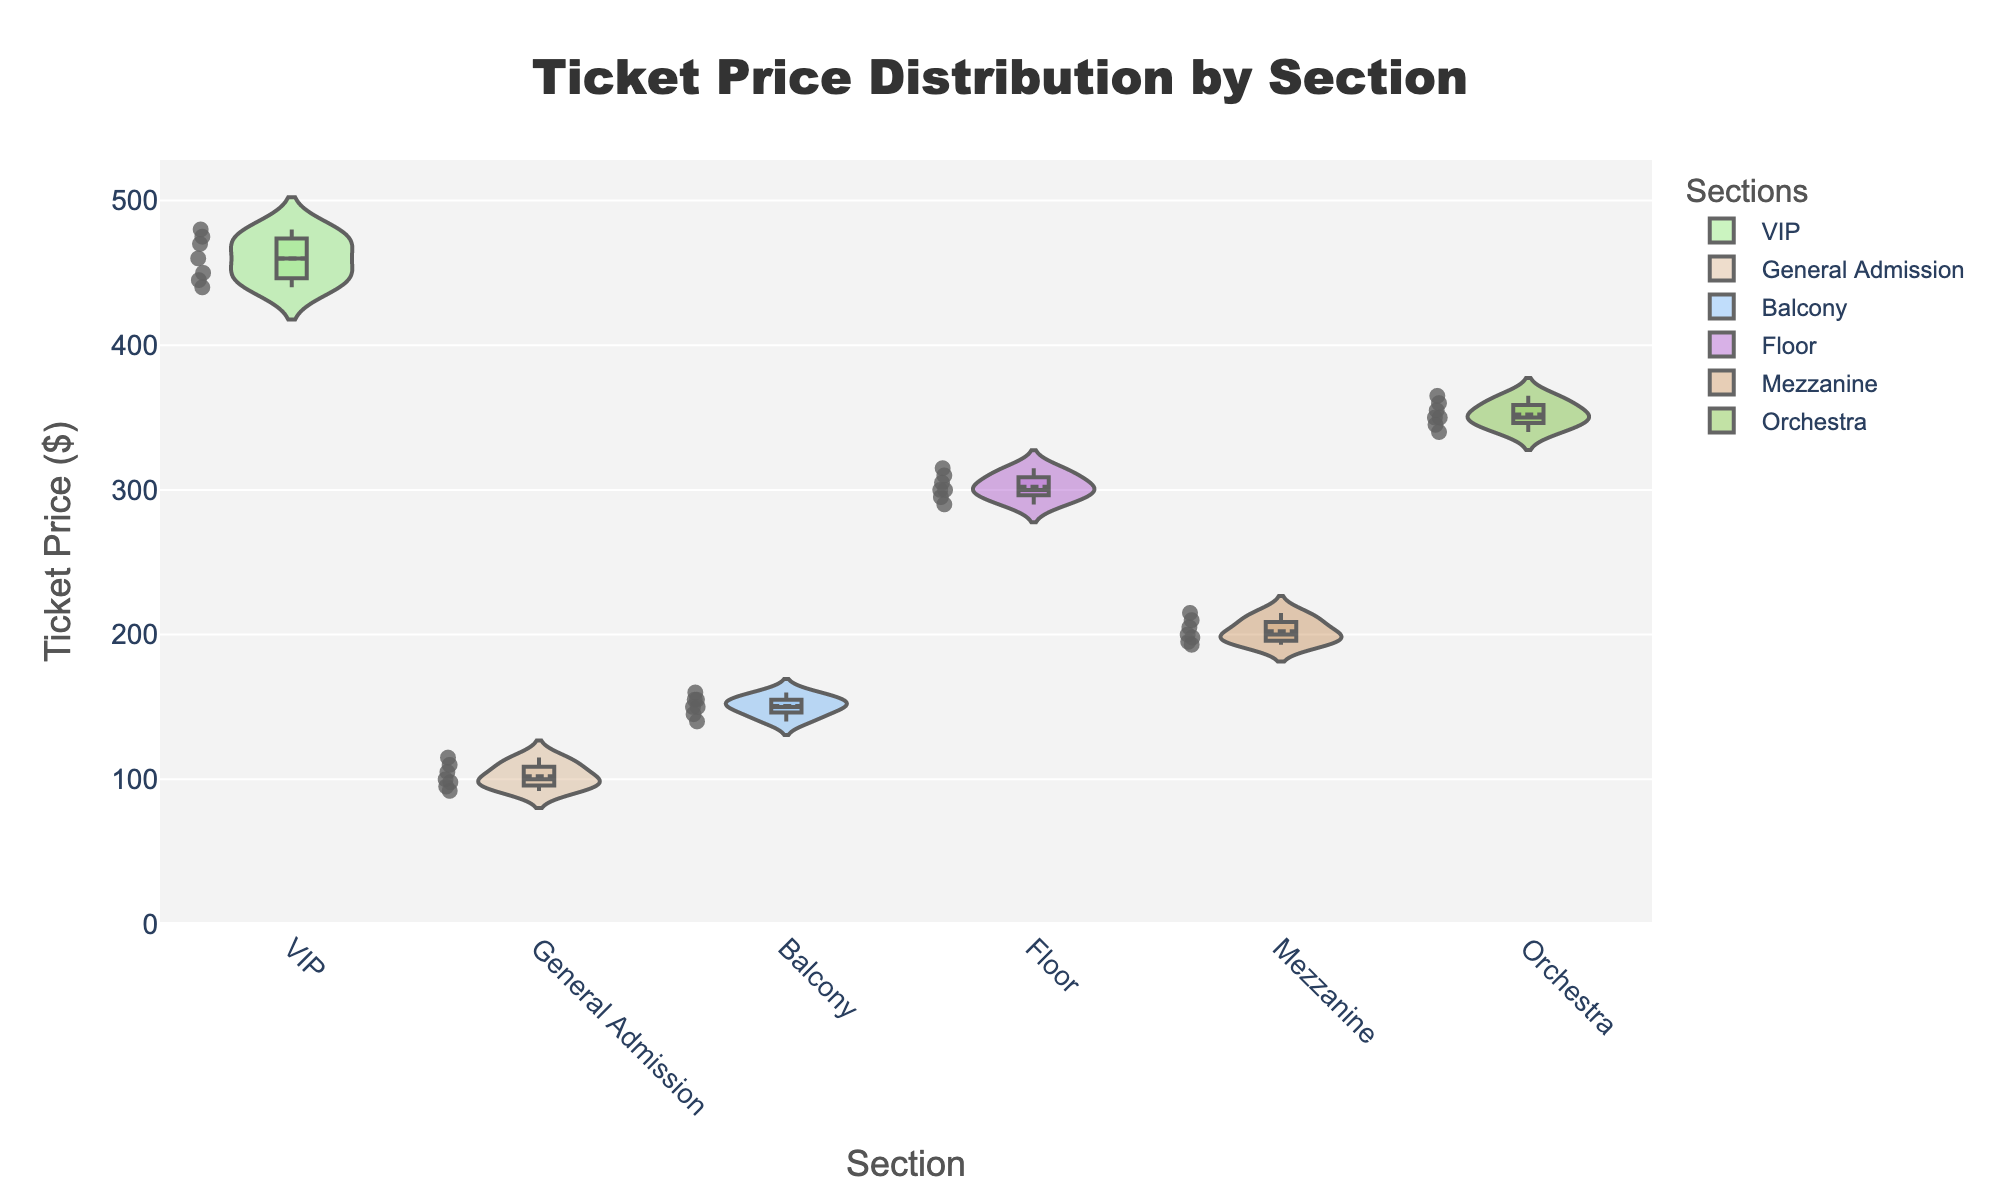What is the title of the figure? The title is usually displayed at the top of the figure and describes the main focus of the data presented.
Answer: Ticket Price Distribution by Section Which section has the highest median ticket price? The median value is typically shown as a line inside the box plot. By comparing the positions of these lines across sections, the VIP section has the highest median line.
Answer: VIP What is the range of ticket prices in the General Admission section? The range is determined by the difference between the maximum and minimum values. For General Admission, the highest value is 115 and the lowest value is 92. Thus, the range is 115 - 92.
Answer: 23 Which section shows the greatest variability in ticket prices? Variability can be observed by the spread of the violin plot. By examining the width and distribution of each violin plot, the Balcony section shows the widest spread.
Answer: Balcony How many sections have a mean ticket price above $200? The mean line inside the box plot is usually visible. By checking each section, the VIP, Floor, and Orchestra sections have mean prices above $200.
Answer: 3 Which section has the ticket price closest to $250? Observing the middle regions of each section, the Mezzanine section has its ticket prices around $200 and $210, which is the closest to $250 when rounding up.
Answer: Mezzanine What can we infer about the ticket price distribution in the Orchestra section? The distribution appears symmetrical with a central box and equally spread whiskers, suggesting a normal distribution. The mean and median conform closely, centered around $350 to $360.
Answer: Symmetrical and centered around $350 to $360 How do the ticket prices for floor seats compare to balcony seats? By comparing the central tendencies, floor seats have higher median and mean prices around $300, whereas balcony seats have lower median and mean prices around $150.
Answer: Floor seats are higher priced What is the difference between the highest and lowest ticket prices in the Orchestra section? The highest observed ticket price in the Orchestra section is $365 and the lowest is $340. The difference is 365 - 340.
Answer: 25 Are there any clear outliers in any of the sections? Outliers are typically shown as distinct points outside the typical range of the violin plot. Observing each section, there are no clear points significantly away from the distribution range.
Answer: No 